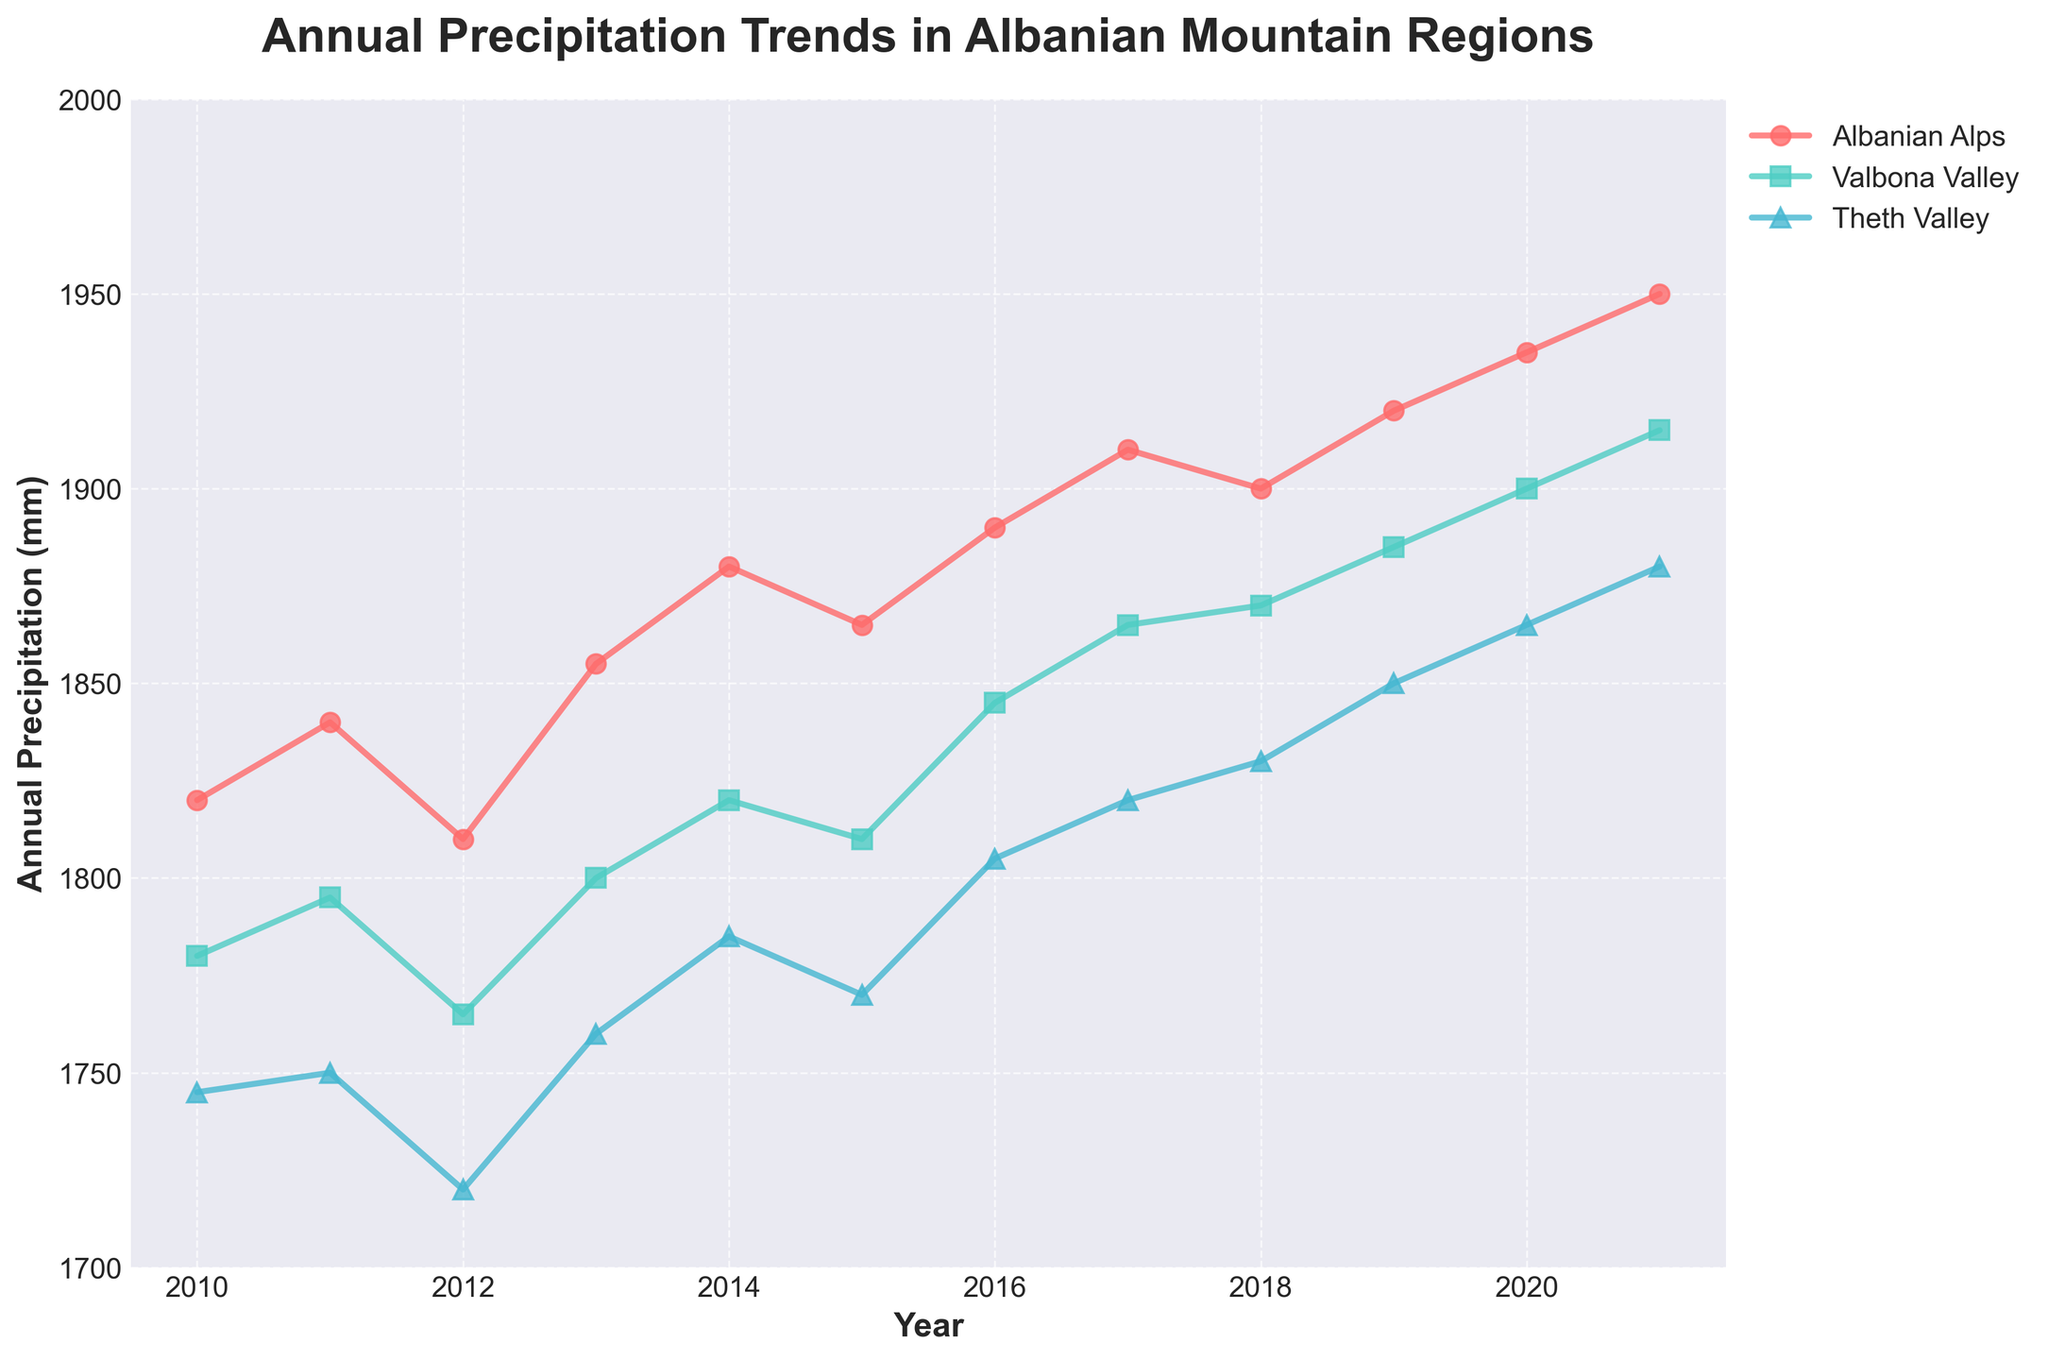What is the title of the plot? The title is located at the top of the plot and is a large, bold text.
Answer: Annual Precipitation Trends in Albanian Mountain Regions What is the Y-axis label? The Y-axis label is the vertically oriented text on the left side of the plot.
Answer: Annual Precipitation (mm) Which region had the highest precipitation in 2020? To find this, look at the data points for the year 2020 and identify the point with the highest Y-axis value.
Answer: Albanian Alps During which year did the Valbona Valley have its lowest recorded precipitation? Find the lowest data point of the Valbona Valley series and check the corresponding year on the X-axis.
Answer: 2012 What is the trend in precipitation for the Albanian Alps region from 2010 to 2021? Observe the line corresponding to the Albanian Alps and note its direction over the years.
Answer: Increasing On average, which region has more precipitation, the Theth Valley or the Valbona Valley? Calculate the average of each region's data points and compare. Theth Valley: (1745+1750+1720+1760+1785+1770+1805+1820+1830+1850+1865+1880)/11 ≈ 1780. Valbona Valley: (1780+1795+1765+1800+1820+1810+1845+1865+1870+1885+1900+1915)/11 ≈ 1840.
Answer: Valbona Valley What was the precipitation difference between 2016 and 2020 in the Albanian Alps? Locate the data points for 2016 and 2020 for the Albanian Alps and subtract the 2016 value from the 2020 value. 1935 - 1890 = 45
Answer: 45 mm Which year saw the biggest increase in precipitation for Theth Valley compared to the previous year? Calculate the year-over-year changes for Theth Valley and identify the largest increase. E.g., 2011-2010: 5, 2012-2011: -30, etc. The 2015-2016 change is 1805-1770 = 35, which is the largest.
Answer: 2016 How many regions are shown in the plot? Count the number of unique series represented by different lines and markers.
Answer: Three In which year was the difference between the precipitation in Valbona Valley and Theth Valley the greatest? Calculate the differences between Valbona Valley and Theth Valley for each year and identify the year with the largest difference. 2021: 1915 - 1880 = 35 mm.
Answer: 2021 